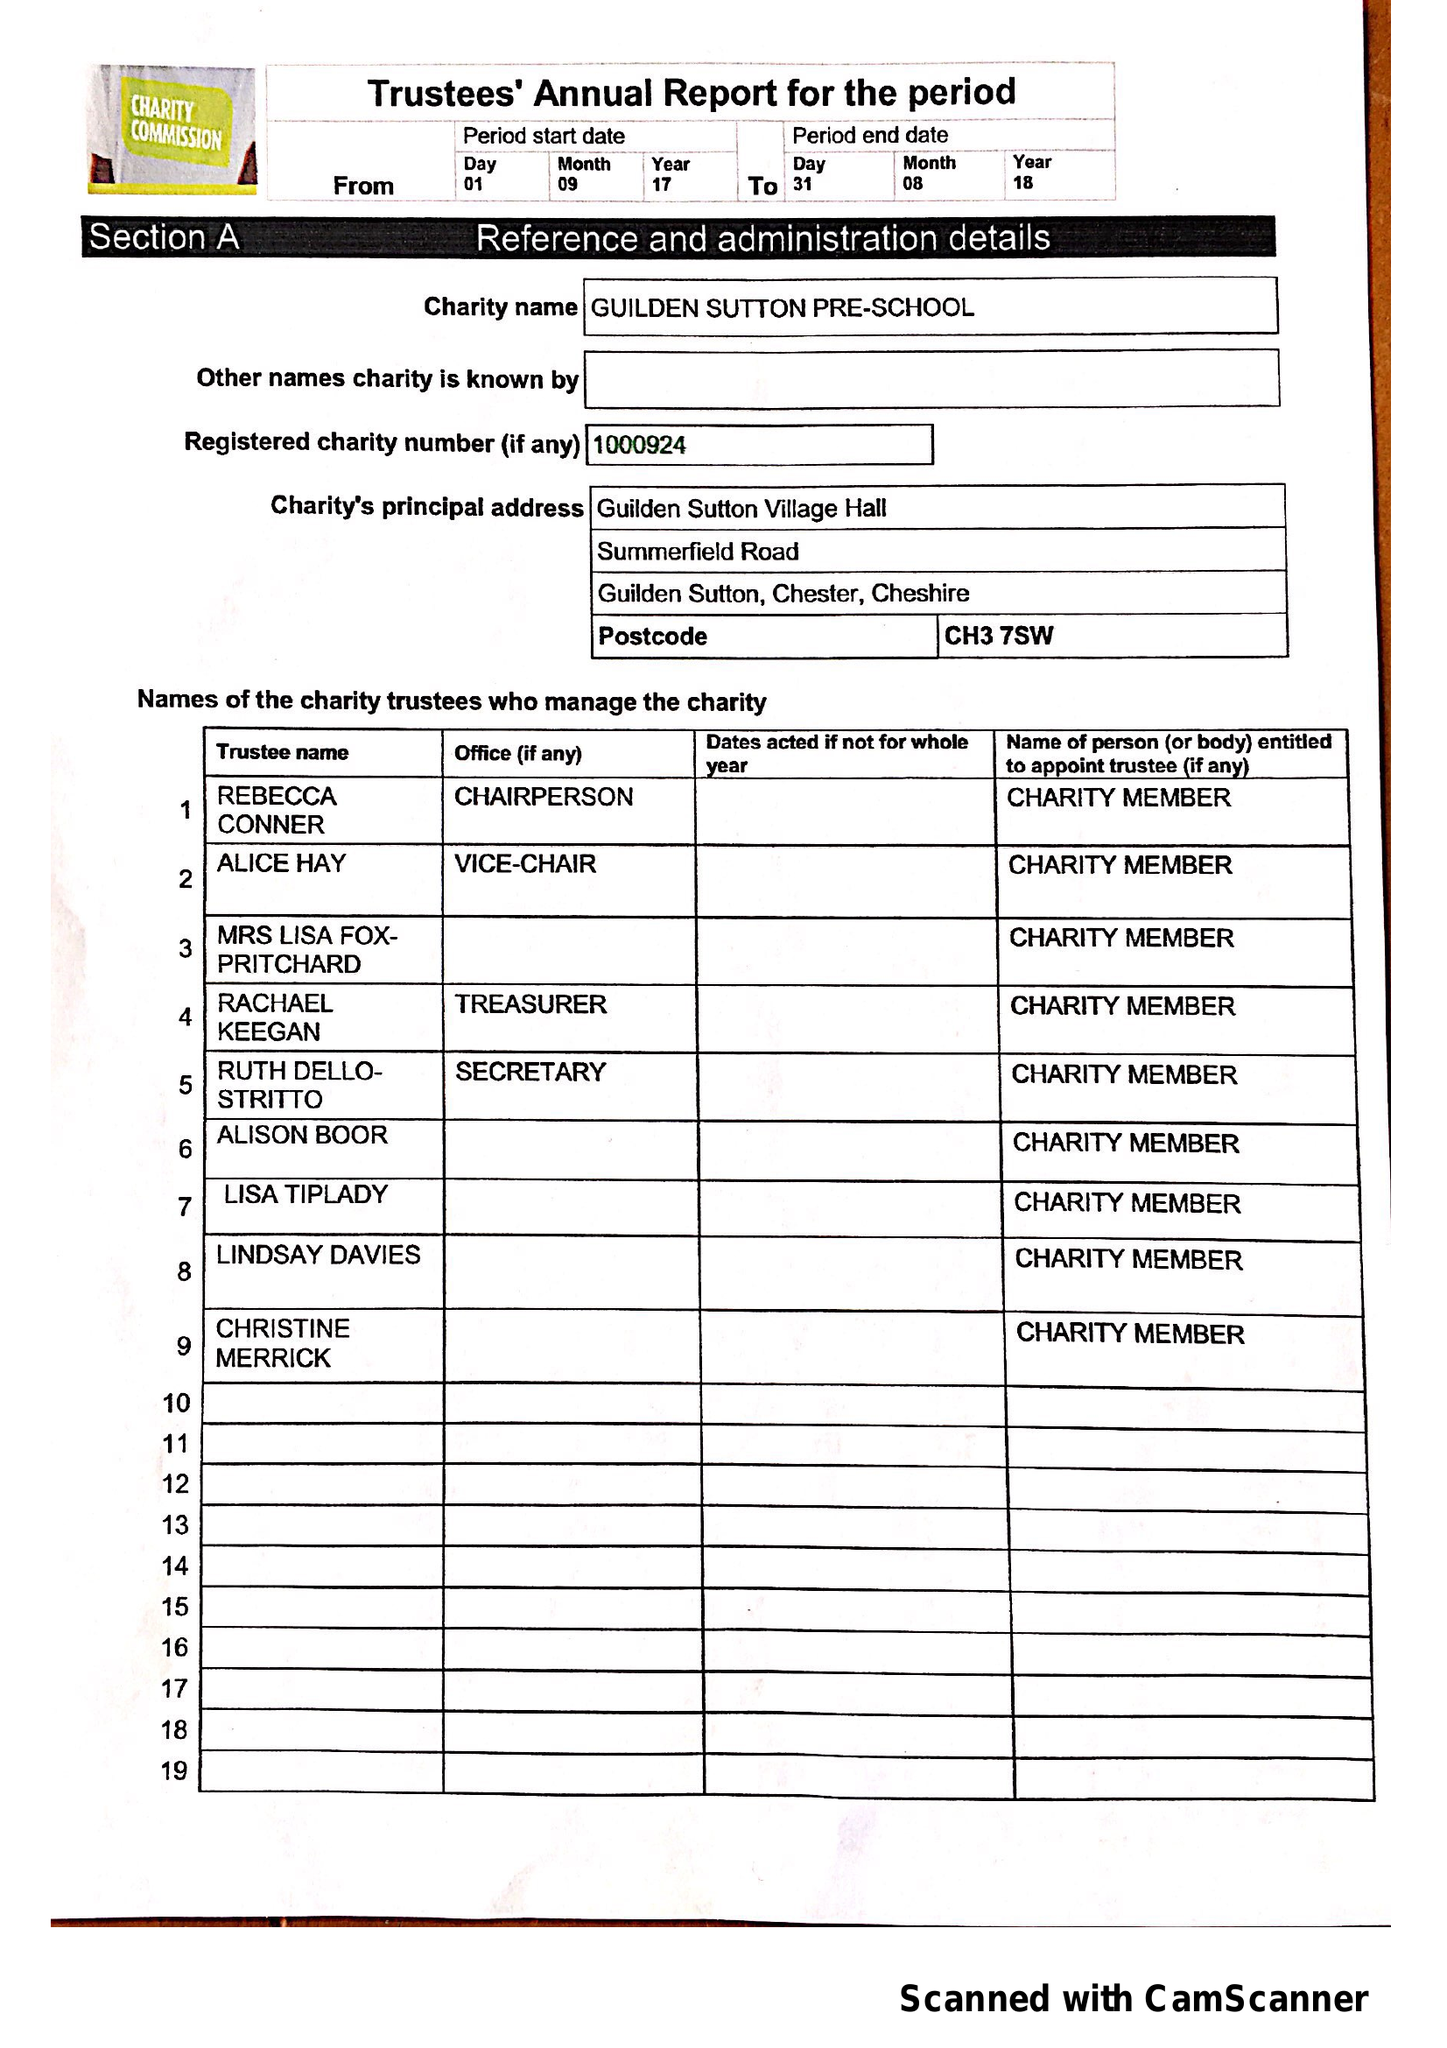What is the value for the address__postcode?
Answer the question using a single word or phrase. CH3 7SW 